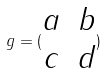<formula> <loc_0><loc_0><loc_500><loc_500>g = ( \begin{matrix} a & b \\ c & d \end{matrix} )</formula> 